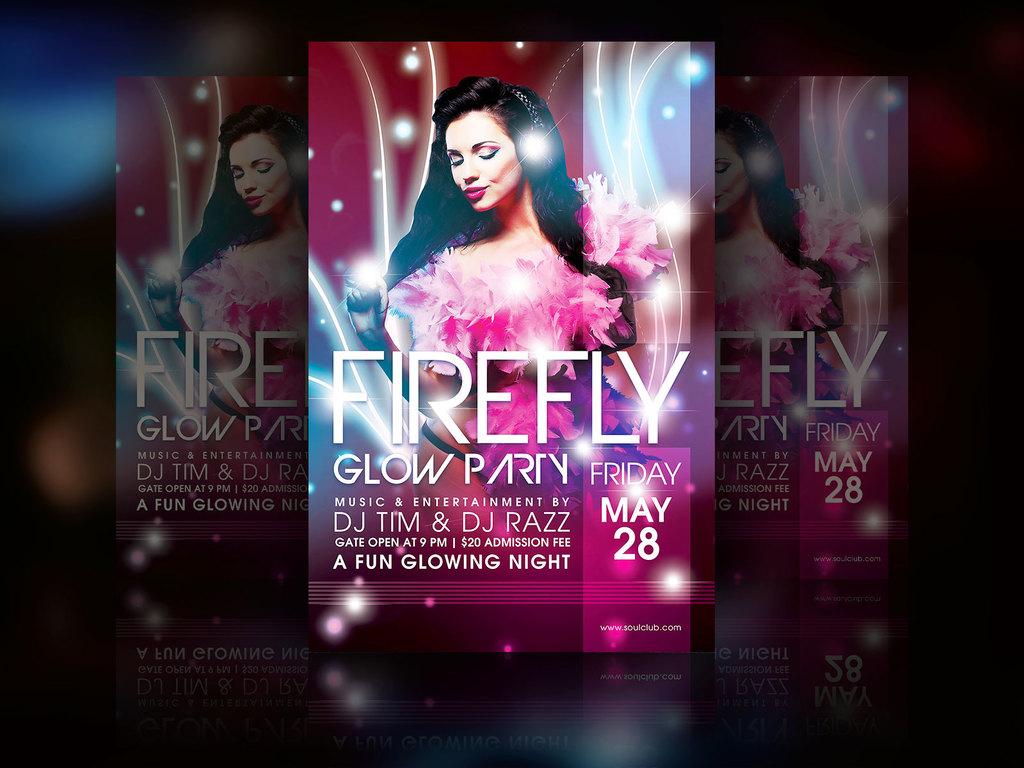Where is this party?
Offer a very short reply. Unanswerable. What is the date of the event?
Provide a short and direct response. May 28. 